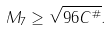<formula> <loc_0><loc_0><loc_500><loc_500>M _ { 7 } \geq \sqrt { 9 6 C ^ { \# } } .</formula> 